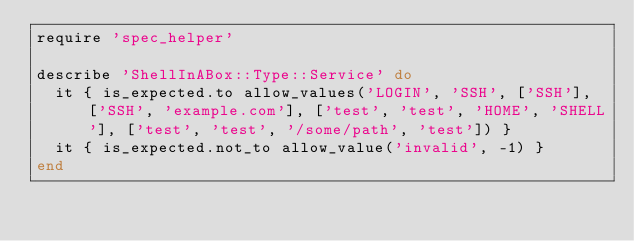Convert code to text. <code><loc_0><loc_0><loc_500><loc_500><_Ruby_>require 'spec_helper'

describe 'ShellInABox::Type::Service' do
  it { is_expected.to allow_values('LOGIN', 'SSH', ['SSH'], ['SSH', 'example.com'], ['test', 'test', 'HOME', 'SHELL'], ['test', 'test', '/some/path', 'test']) }
  it { is_expected.not_to allow_value('invalid', -1) }
end
</code> 